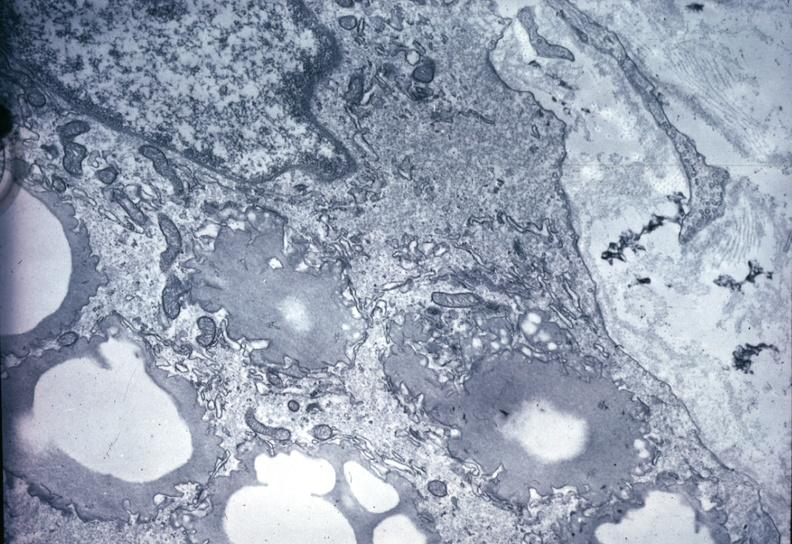s newborn cord around neck present?
Answer the question using a single word or phrase. No 